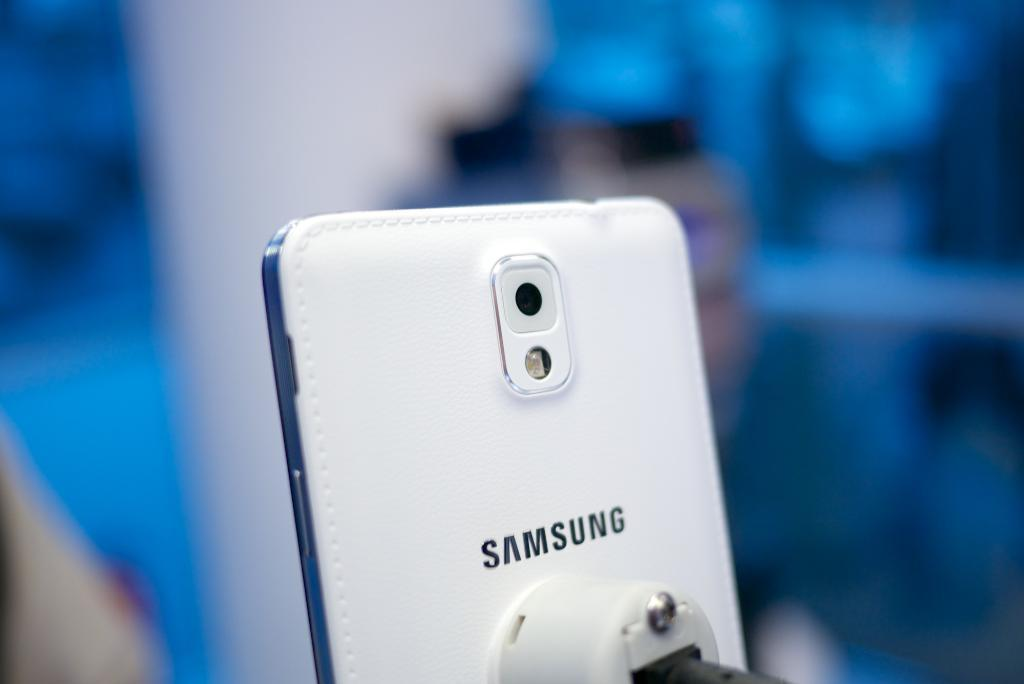<image>
Render a clear and concise summary of the photo. A white Samsung cell phone with the camera displayed 